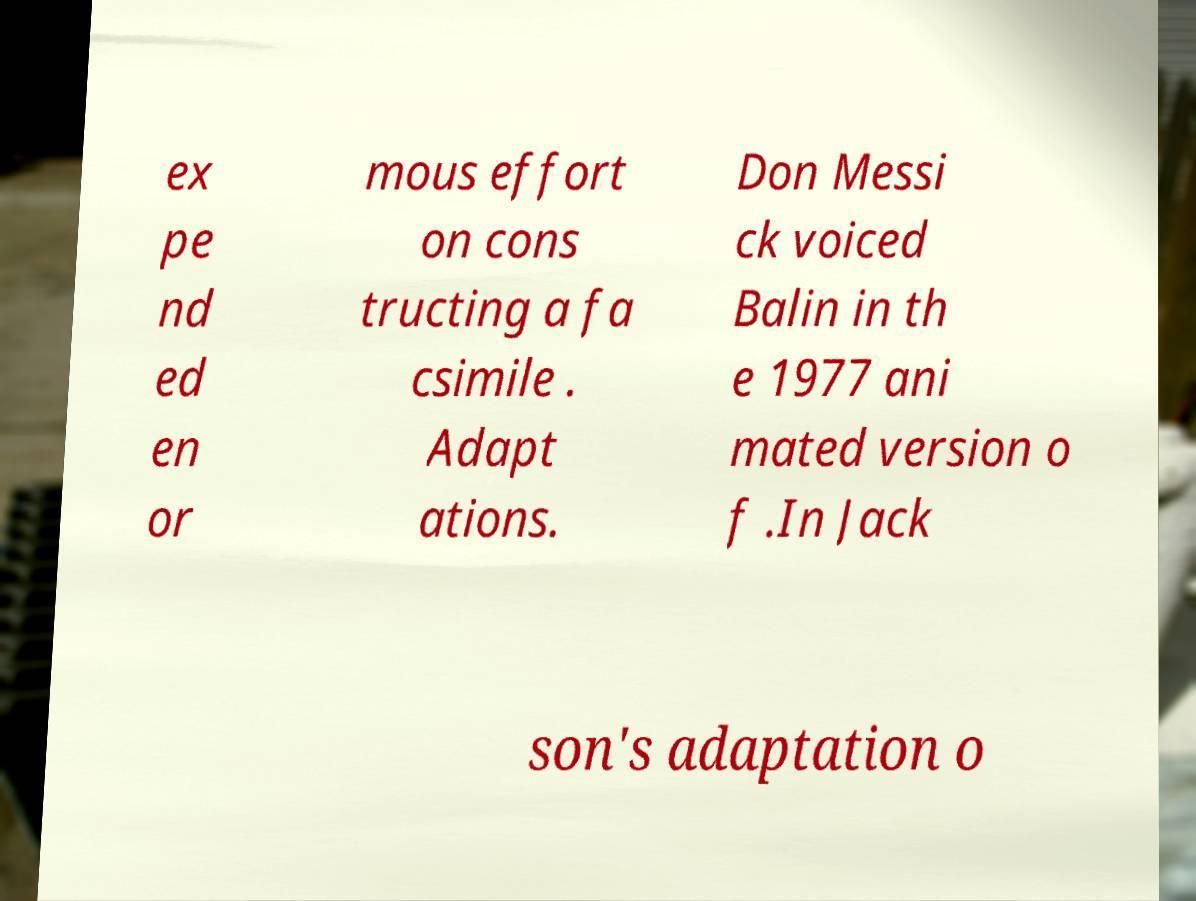Can you accurately transcribe the text from the provided image for me? ex pe nd ed en or mous effort on cons tructing a fa csimile . Adapt ations. Don Messi ck voiced Balin in th e 1977 ani mated version o f .In Jack son's adaptation o 